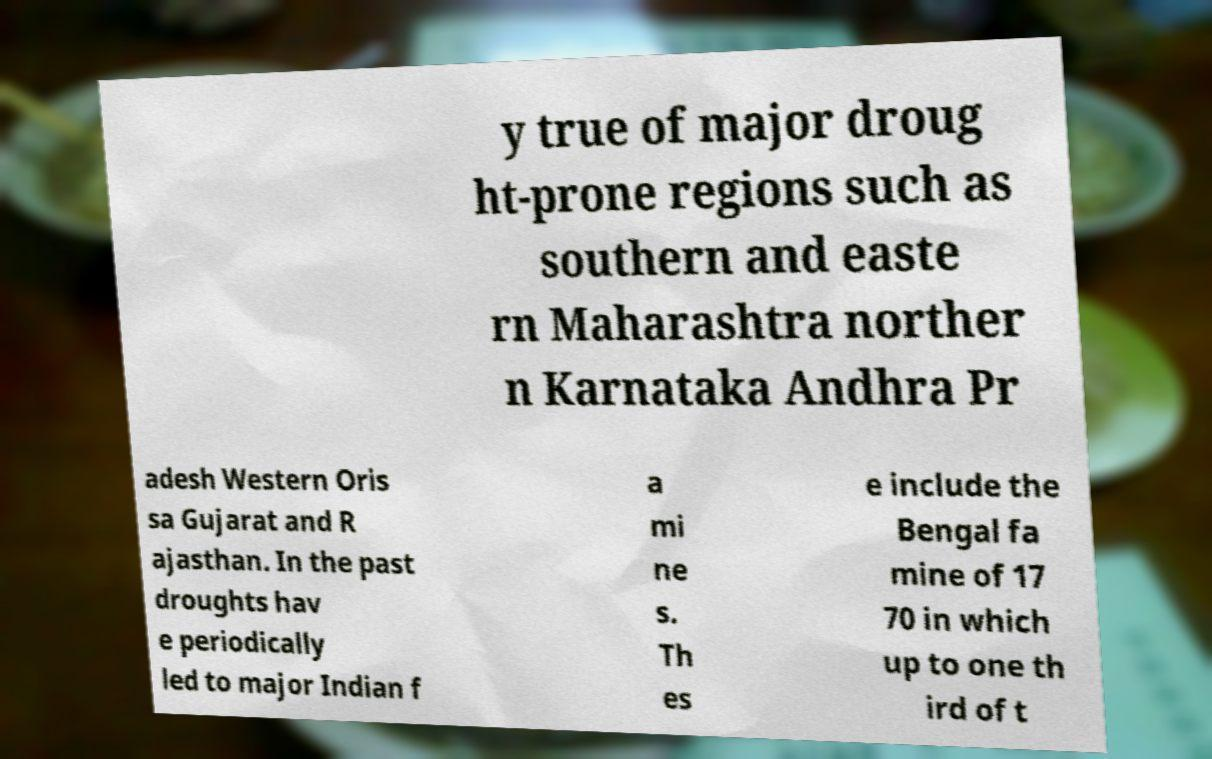Please identify and transcribe the text found in this image. y true of major droug ht-prone regions such as southern and easte rn Maharashtra norther n Karnataka Andhra Pr adesh Western Oris sa Gujarat and R ajasthan. In the past droughts hav e periodically led to major Indian f a mi ne s. Th es e include the Bengal fa mine of 17 70 in which up to one th ird of t 